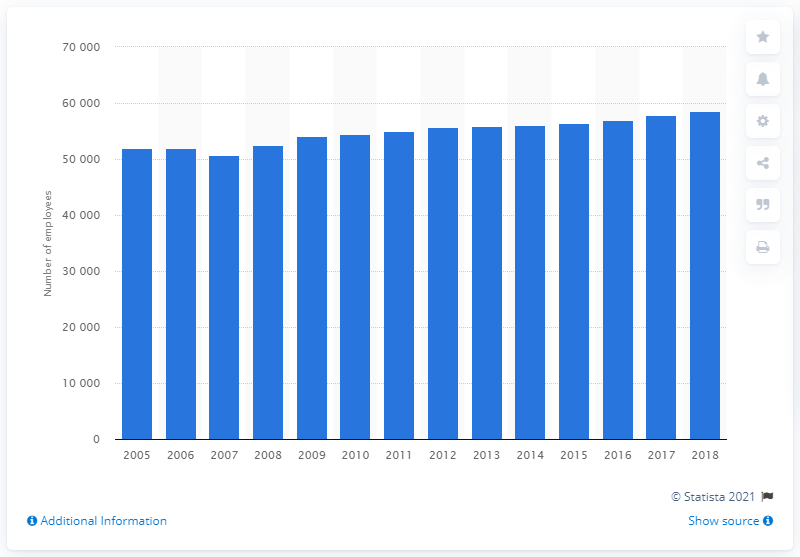Indicate a few pertinent items in this graphic. In 2007, there were 5,076 nurses employed in Denmark. In 2007, the number of nurses in Denmark increased. In 2018, there were 58,509 nurses employed in Denmark. 